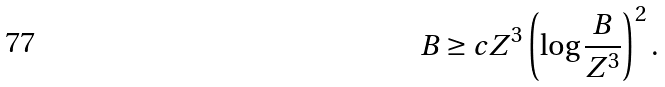Convert formula to latex. <formula><loc_0><loc_0><loc_500><loc_500>B \geq c Z ^ { 3 } \left ( \log \frac { B } { Z ^ { 3 } } \right ) ^ { 2 } .</formula> 